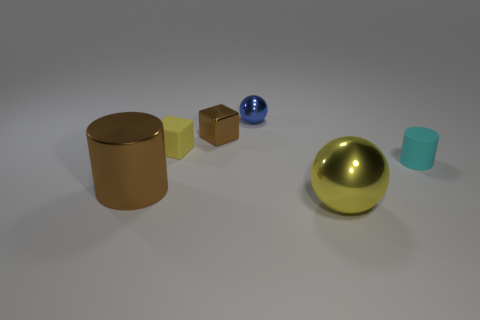What number of balls are tiny blue metal things or large objects?
Your answer should be very brief. 2. Does the shiny thing that is to the left of the brown shiny cube have the same shape as the cyan rubber object?
Provide a succinct answer. Yes. Are there more matte blocks that are left of the cyan cylinder than tiny gray metal spheres?
Give a very brief answer. Yes. What is the color of the metallic thing that is the same size as the yellow ball?
Provide a succinct answer. Brown. How many things are metal objects that are to the right of the large brown thing or gray shiny blocks?
Keep it short and to the point. 3. There is a large shiny thing that is the same color as the shiny block; what shape is it?
Give a very brief answer. Cylinder. There is a yellow object on the right side of the small brown block behind the brown cylinder; what is it made of?
Keep it short and to the point. Metal. Is there a large cyan thing that has the same material as the small brown block?
Your response must be concise. No. There is a sphere that is in front of the tiny brown metal object; is there a tiny matte block on the left side of it?
Your answer should be compact. Yes. What is the material of the yellow object that is behind the cyan cylinder?
Give a very brief answer. Rubber. 